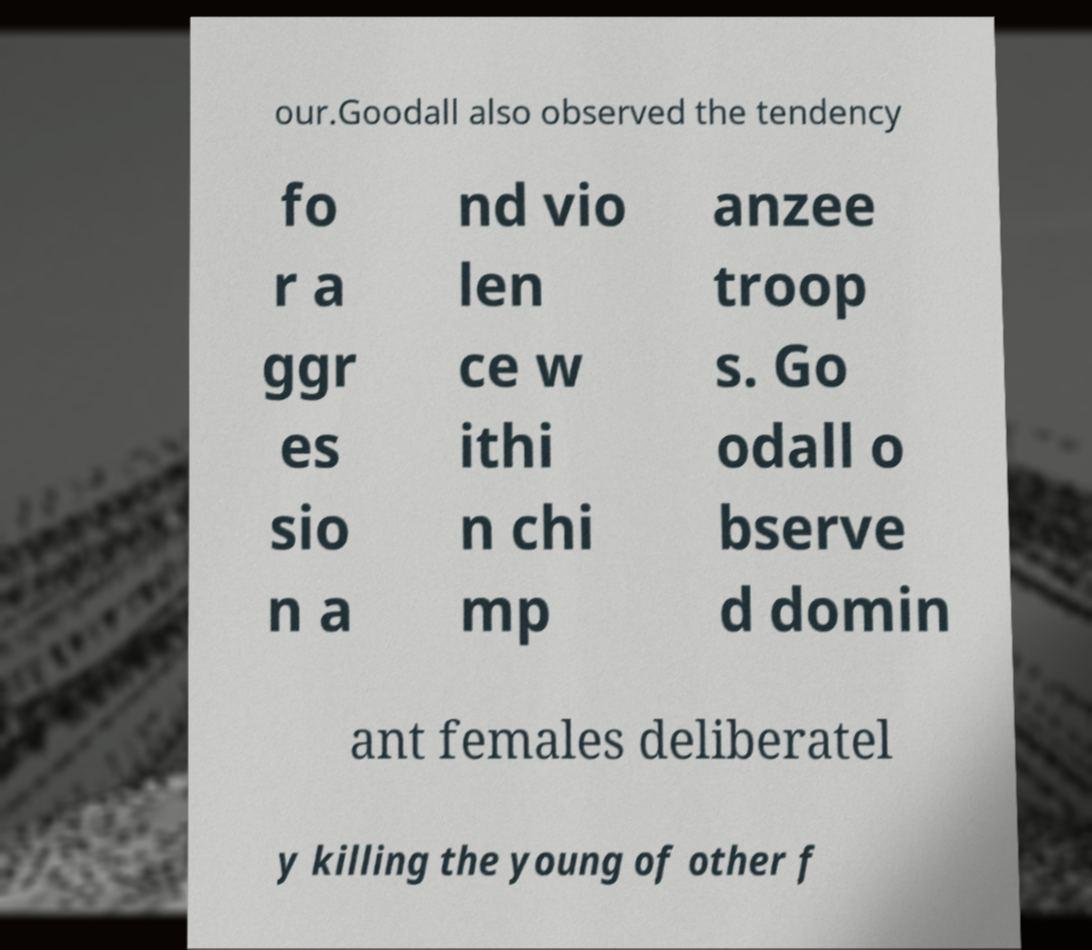Please read and relay the text visible in this image. What does it say? our.Goodall also observed the tendency fo r a ggr es sio n a nd vio len ce w ithi n chi mp anzee troop s. Go odall o bserve d domin ant females deliberatel y killing the young of other f 